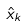<formula> <loc_0><loc_0><loc_500><loc_500>\hat { x } _ { k }</formula> 